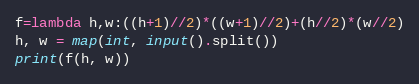Convert code to text. <code><loc_0><loc_0><loc_500><loc_500><_Python_>f=lambda h,w:((h+1)//2)*((w+1)//2)+(h//2)*(w//2)
h, w = map(int, input().split())
print(f(h, w))</code> 